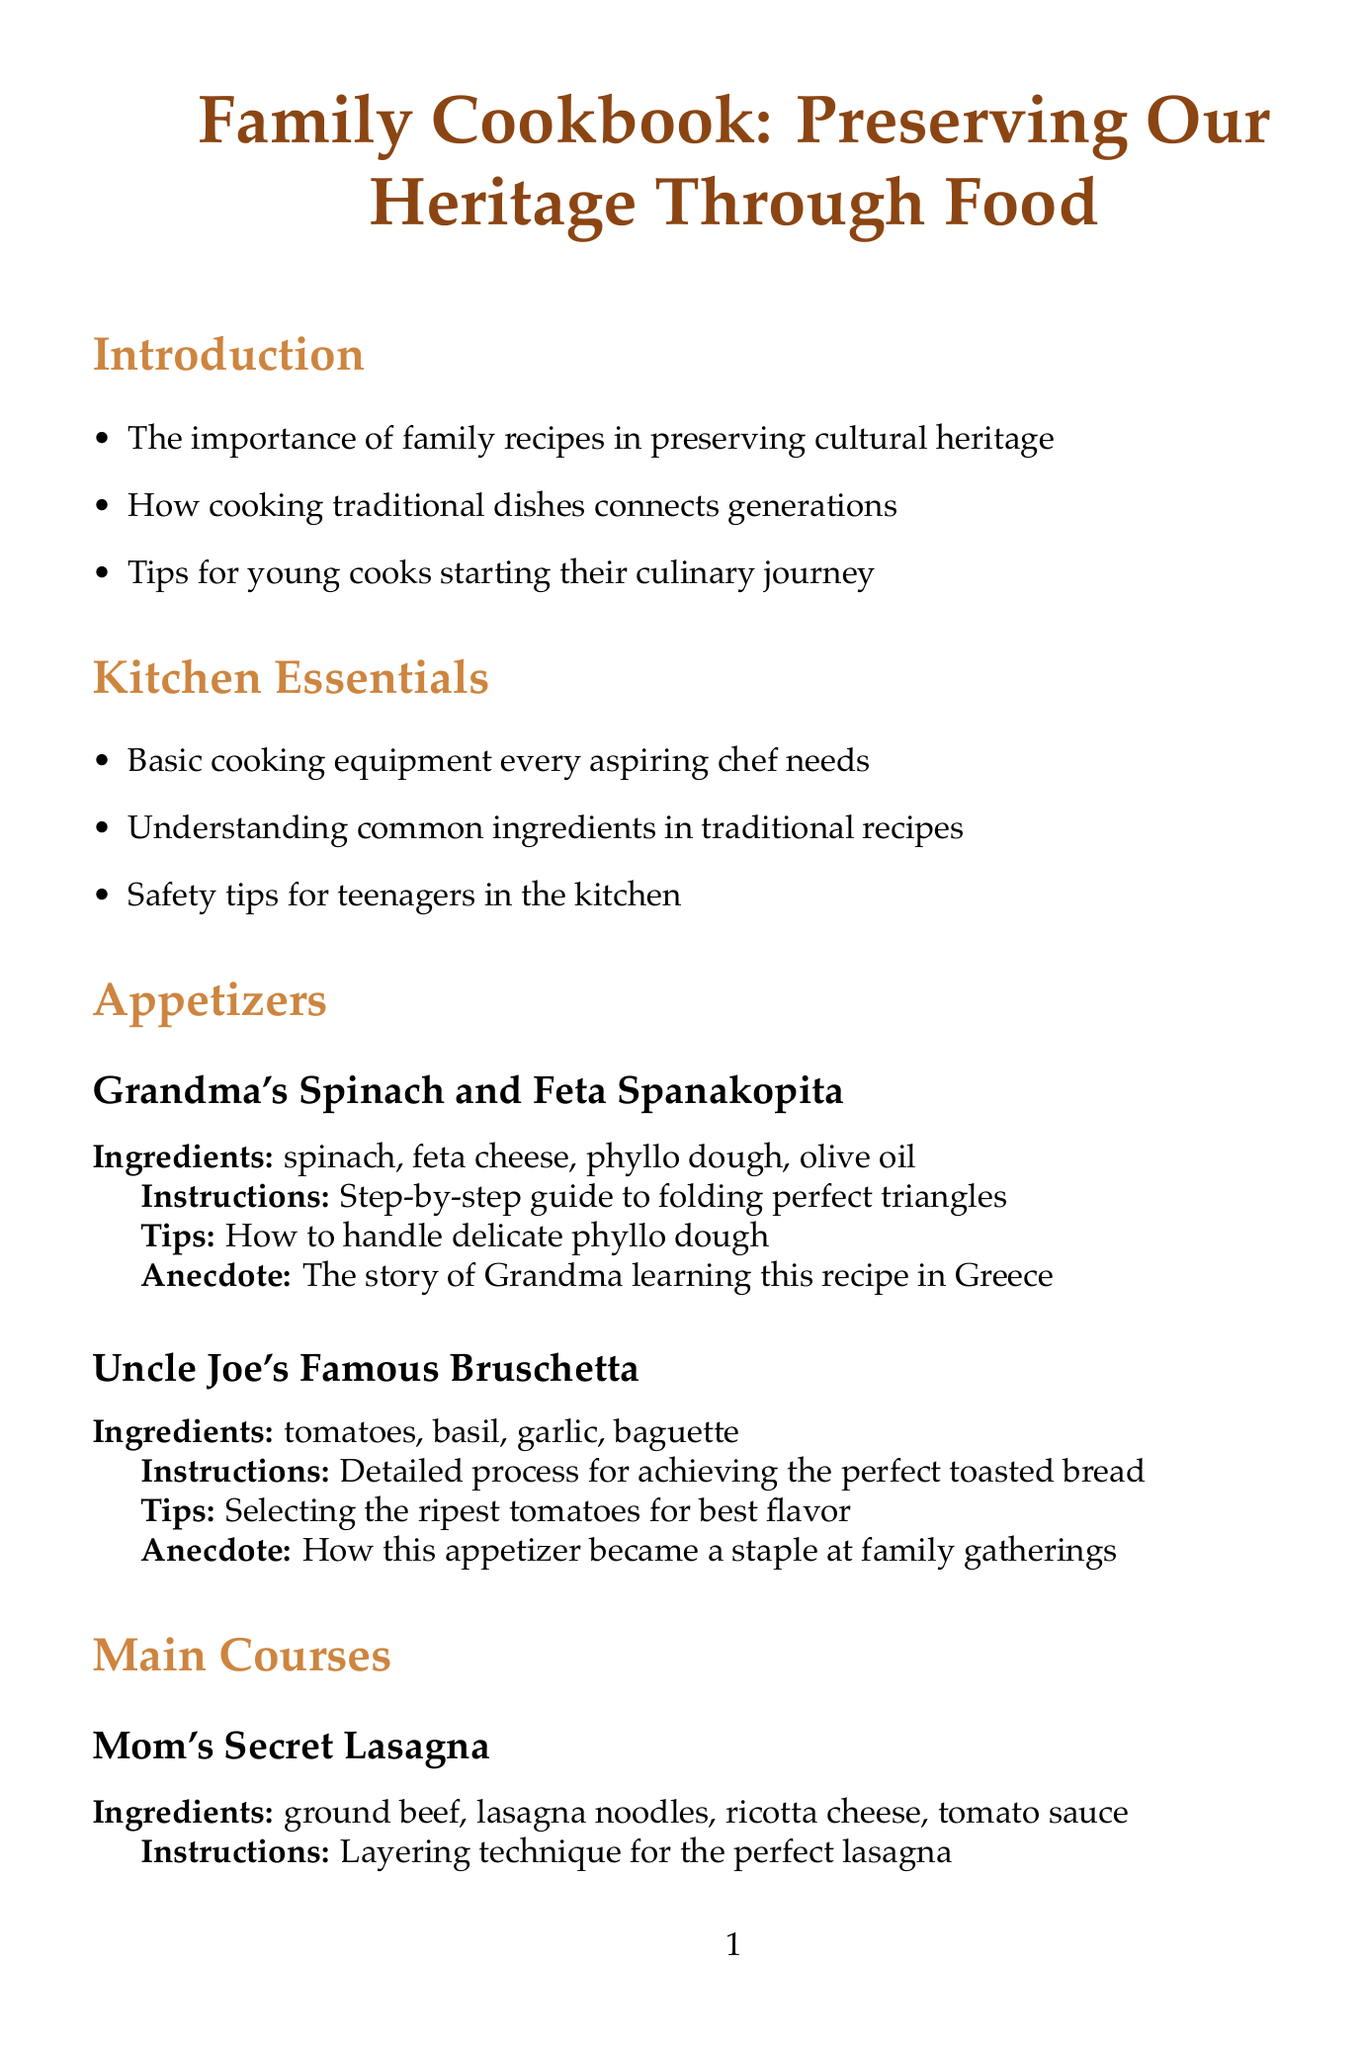What is the title of the cookbook? The title of the cookbook is mentioned at the beginning of the document.
Answer: Family Cookbook: Preserving Our Heritage Through Food Who is the author of the "Grandma's Spinach and Feta Spanakopita" recipe? The recipe is attributed to a family member named Grandma.
Answer: Grandma What ingredients are used in Mom's Secret Lasagna? The ingredients are listed under the recipe section for easy reference.
Answer: ground beef, lasagna noodles, ricotta cheese, tomato sauce What cooking technique is emphasized for Dad's Grilled Lemon Herb Chicken? The instructions for this recipe highlight the grilling technique.
Answer: Mastering the grill What safety tips for teenagers in the kitchen are mentioned? Safety tips are provided in the Kitchen Essentials section.
Answer: Safety tips for teenagers in the kitchen What is one suggested way to involve younger siblings in cooking? The Cooking Together section outlines strategies for family involvement in cooking.
Answer: Suggestions for involving younger siblings in the cooking process How should the perfect flaky crust be crafted? The instructions for Aunt Sarah's Apple Pie detail this process.
Answer: Crafting the perfect flaky crust What is the focus of the section on preserving family recipes? This section provides guidance on recording and documenting recipes.
Answer: Tips for accurately measuring and recording recipes What does the conclusion encourage regarding family recipes? The conclusion summarizes the document's intent regarding cooking traditions.
Answer: Encouragement for experimenting and creating new family recipes 